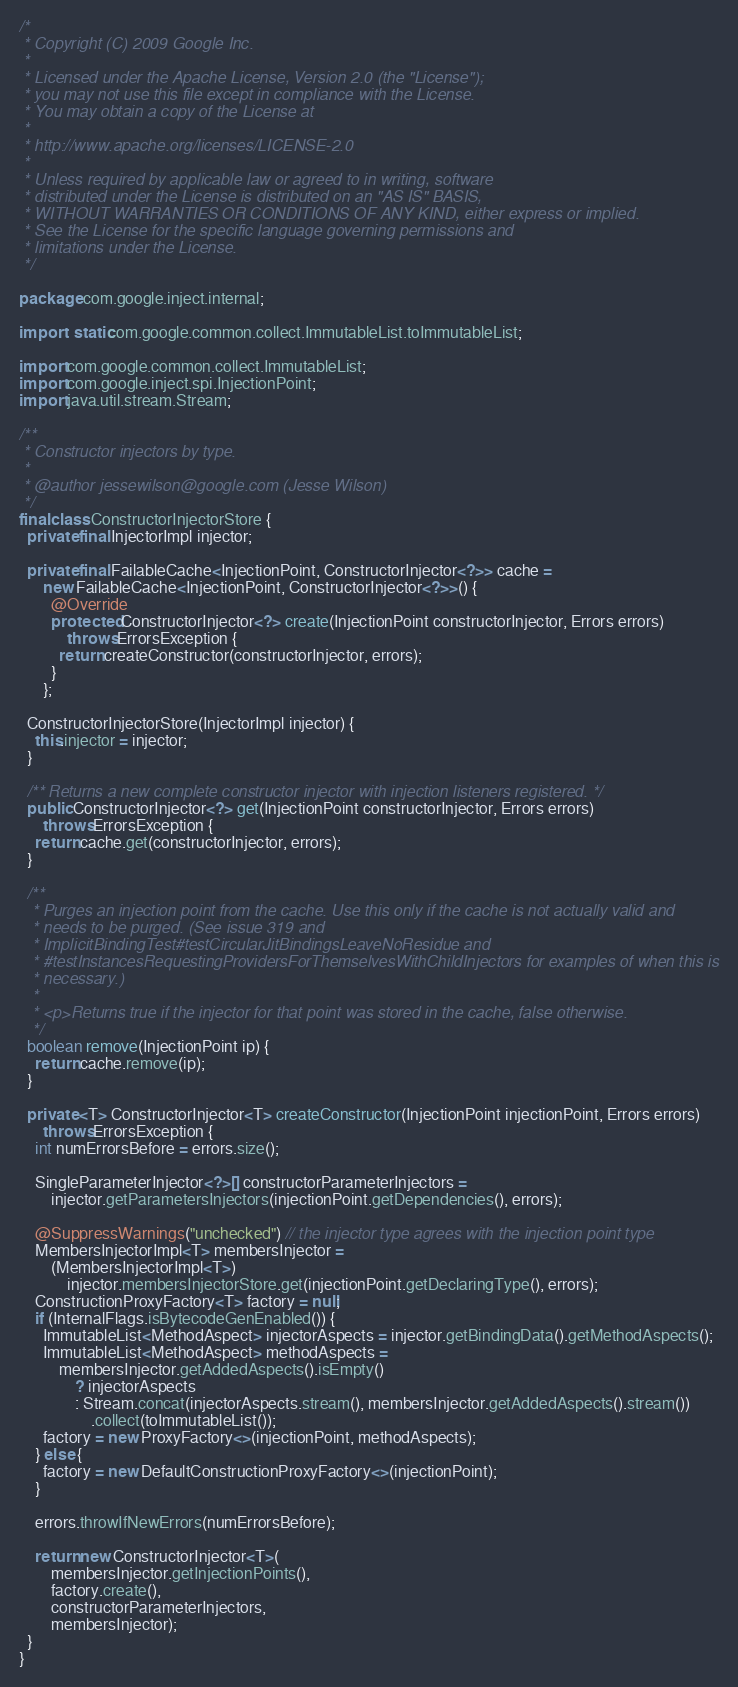<code> <loc_0><loc_0><loc_500><loc_500><_Java_>/*
 * Copyright (C) 2009 Google Inc.
 *
 * Licensed under the Apache License, Version 2.0 (the "License");
 * you may not use this file except in compliance with the License.
 * You may obtain a copy of the License at
 *
 * http://www.apache.org/licenses/LICENSE-2.0
 *
 * Unless required by applicable law or agreed to in writing, software
 * distributed under the License is distributed on an "AS IS" BASIS,
 * WITHOUT WARRANTIES OR CONDITIONS OF ANY KIND, either express or implied.
 * See the License for the specific language governing permissions and
 * limitations under the License.
 */

package com.google.inject.internal;

import static com.google.common.collect.ImmutableList.toImmutableList;

import com.google.common.collect.ImmutableList;
import com.google.inject.spi.InjectionPoint;
import java.util.stream.Stream;

/**
 * Constructor injectors by type.
 *
 * @author jessewilson@google.com (Jesse Wilson)
 */
final class ConstructorInjectorStore {
  private final InjectorImpl injector;

  private final FailableCache<InjectionPoint, ConstructorInjector<?>> cache =
      new FailableCache<InjectionPoint, ConstructorInjector<?>>() {
        @Override
        protected ConstructorInjector<?> create(InjectionPoint constructorInjector, Errors errors)
            throws ErrorsException {
          return createConstructor(constructorInjector, errors);
        }
      };

  ConstructorInjectorStore(InjectorImpl injector) {
    this.injector = injector;
  }

  /** Returns a new complete constructor injector with injection listeners registered. */
  public ConstructorInjector<?> get(InjectionPoint constructorInjector, Errors errors)
      throws ErrorsException {
    return cache.get(constructorInjector, errors);
  }

  /**
   * Purges an injection point from the cache. Use this only if the cache is not actually valid and
   * needs to be purged. (See issue 319 and
   * ImplicitBindingTest#testCircularJitBindingsLeaveNoResidue and
   * #testInstancesRequestingProvidersForThemselvesWithChildInjectors for examples of when this is
   * necessary.)
   *
   * <p>Returns true if the injector for that point was stored in the cache, false otherwise.
   */
  boolean remove(InjectionPoint ip) {
    return cache.remove(ip);
  }

  private <T> ConstructorInjector<T> createConstructor(InjectionPoint injectionPoint, Errors errors)
      throws ErrorsException {
    int numErrorsBefore = errors.size();

    SingleParameterInjector<?>[] constructorParameterInjectors =
        injector.getParametersInjectors(injectionPoint.getDependencies(), errors);

    @SuppressWarnings("unchecked") // the injector type agrees with the injection point type
    MembersInjectorImpl<T> membersInjector =
        (MembersInjectorImpl<T>)
            injector.membersInjectorStore.get(injectionPoint.getDeclaringType(), errors);
    ConstructionProxyFactory<T> factory = null;
    if (InternalFlags.isBytecodeGenEnabled()) {
      ImmutableList<MethodAspect> injectorAspects = injector.getBindingData().getMethodAspects();
      ImmutableList<MethodAspect> methodAspects =
          membersInjector.getAddedAspects().isEmpty()
              ? injectorAspects
              : Stream.concat(injectorAspects.stream(), membersInjector.getAddedAspects().stream())
                  .collect(toImmutableList());
      factory = new ProxyFactory<>(injectionPoint, methodAspects);
    } else {
      factory = new DefaultConstructionProxyFactory<>(injectionPoint);
    }

    errors.throwIfNewErrors(numErrorsBefore);

    return new ConstructorInjector<T>(
        membersInjector.getInjectionPoints(),
        factory.create(),
        constructorParameterInjectors,
        membersInjector);
  }
}
</code> 